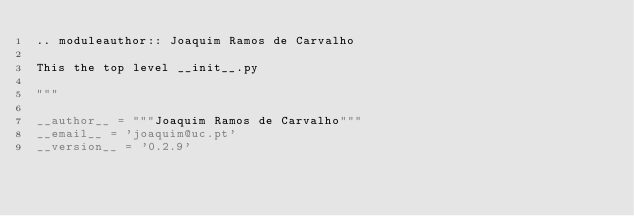<code> <loc_0><loc_0><loc_500><loc_500><_Python_>.. moduleauthor:: Joaquim Ramos de Carvalho

This the top level __init__.py

"""

__author__ = """Joaquim Ramos de Carvalho"""
__email__ = 'joaquim@uc.pt'
__version__ = '0.2.9'
</code> 